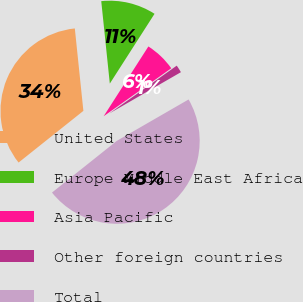<chart> <loc_0><loc_0><loc_500><loc_500><pie_chart><fcel>United States<fcel>Europe Middle East Africa<fcel>Asia Pacific<fcel>Other foreign countries<fcel>Total<nl><fcel>34.07%<fcel>10.72%<fcel>6.11%<fcel>1.49%<fcel>47.62%<nl></chart> 